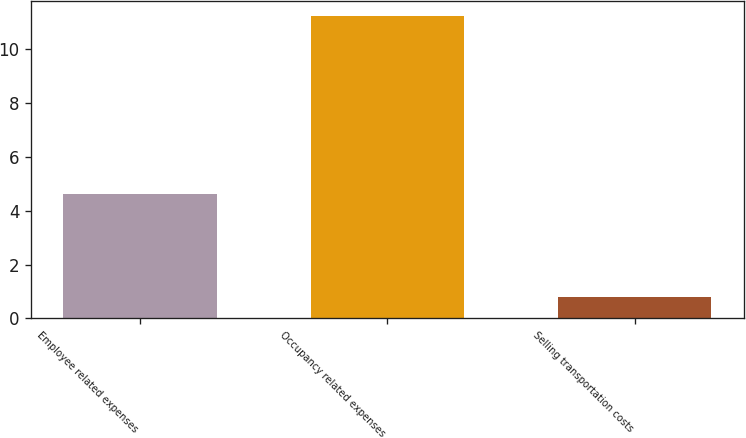Convert chart. <chart><loc_0><loc_0><loc_500><loc_500><bar_chart><fcel>Employee related expenses<fcel>Occupancy related expenses<fcel>Selling transportation costs<nl><fcel>4.6<fcel>11.2<fcel>0.8<nl></chart> 